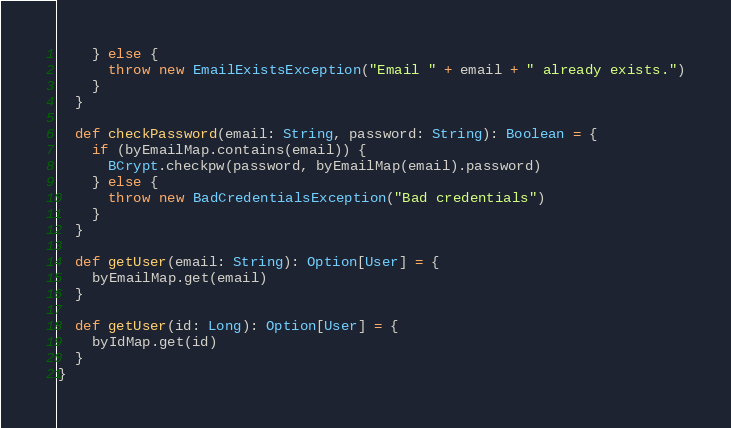Convert code to text. <code><loc_0><loc_0><loc_500><loc_500><_Scala_>    } else {
      throw new EmailExistsException("Email " + email + " already exists.")
    }
  }

  def checkPassword(email: String, password: String): Boolean = {
    if (byEmailMap.contains(email)) {
      BCrypt.checkpw(password, byEmailMap(email).password)
    } else {
      throw new BadCredentialsException("Bad credentials")
    }
  }

  def getUser(email: String): Option[User] = {
    byEmailMap.get(email)
  }

  def getUser(id: Long): Option[User] = {
    byIdMap.get(id)
  }
}
</code> 